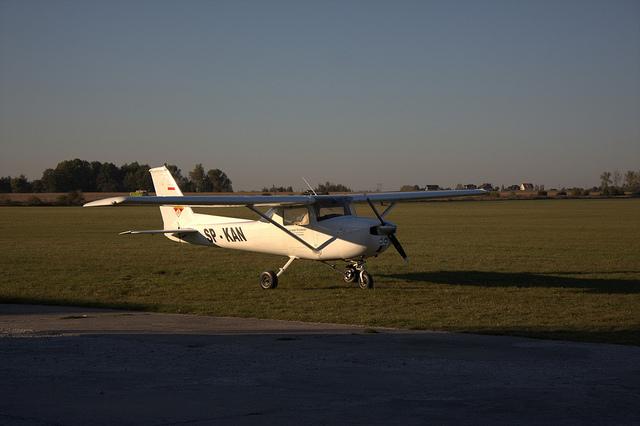Is this airplane on the runway?
Short answer required. No. How many wheels does the plane have?
Answer briefly. 3. How many windows does the plane have excluding the pilot area?
Quick response, please. 0. Are there people inside the plane?
Quick response, please. No. How many propeller blades are there all together?
Be succinct. 2. How many towers can be seen?
Write a very short answer. 0. Can this plane land on water?
Keep it brief. No. Are those propeller planes?
Answer briefly. Yes. Where is this picture taken?
Answer briefly. Airport. What is under the plane?
Be succinct. Grass. How many airlines are represented in this image?
Answer briefly. 1. Why do people come to this location?
Write a very short answer. To fly. Where is the plane parked?
Write a very short answer. Grass. Are there any flowers in the field?
Keep it brief. No. What type of airplane is this?
Keep it brief. Single engine. Is this a commercial or private plane?
Quick response, please. Private. Is the plane parked on the pavement?
Quick response, please. No. What is in the picture?
Write a very short answer. Plane. What phase of flight is the plane in?
Keep it brief. Take off. What is written on the side of the airplane?
Answer briefly. Sp-kan. Would this be a suitable plane for an international flight?
Quick response, please. No. Where is the plane?
Concise answer only. On grass. What is the land formation in the background?
Write a very short answer. Flat. Is this a big airport?
Give a very brief answer. No. 